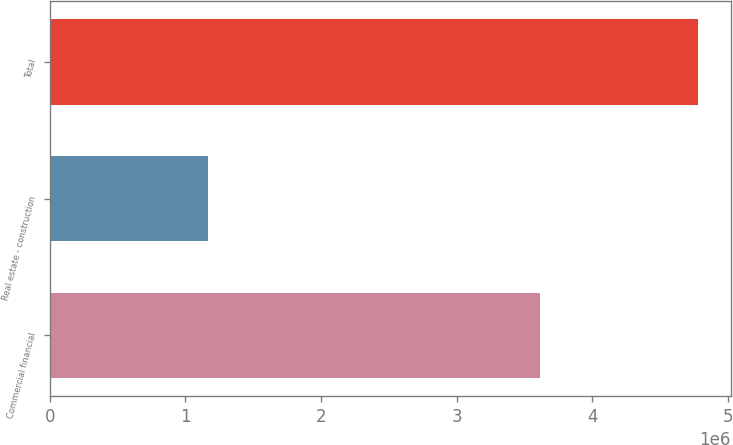Convert chart. <chart><loc_0><loc_0><loc_500><loc_500><bar_chart><fcel>Commercial financial<fcel>Real estate - construction<fcel>Total<nl><fcel>3.61045e+06<fcel>1.17055e+06<fcel>4.781e+06<nl></chart> 